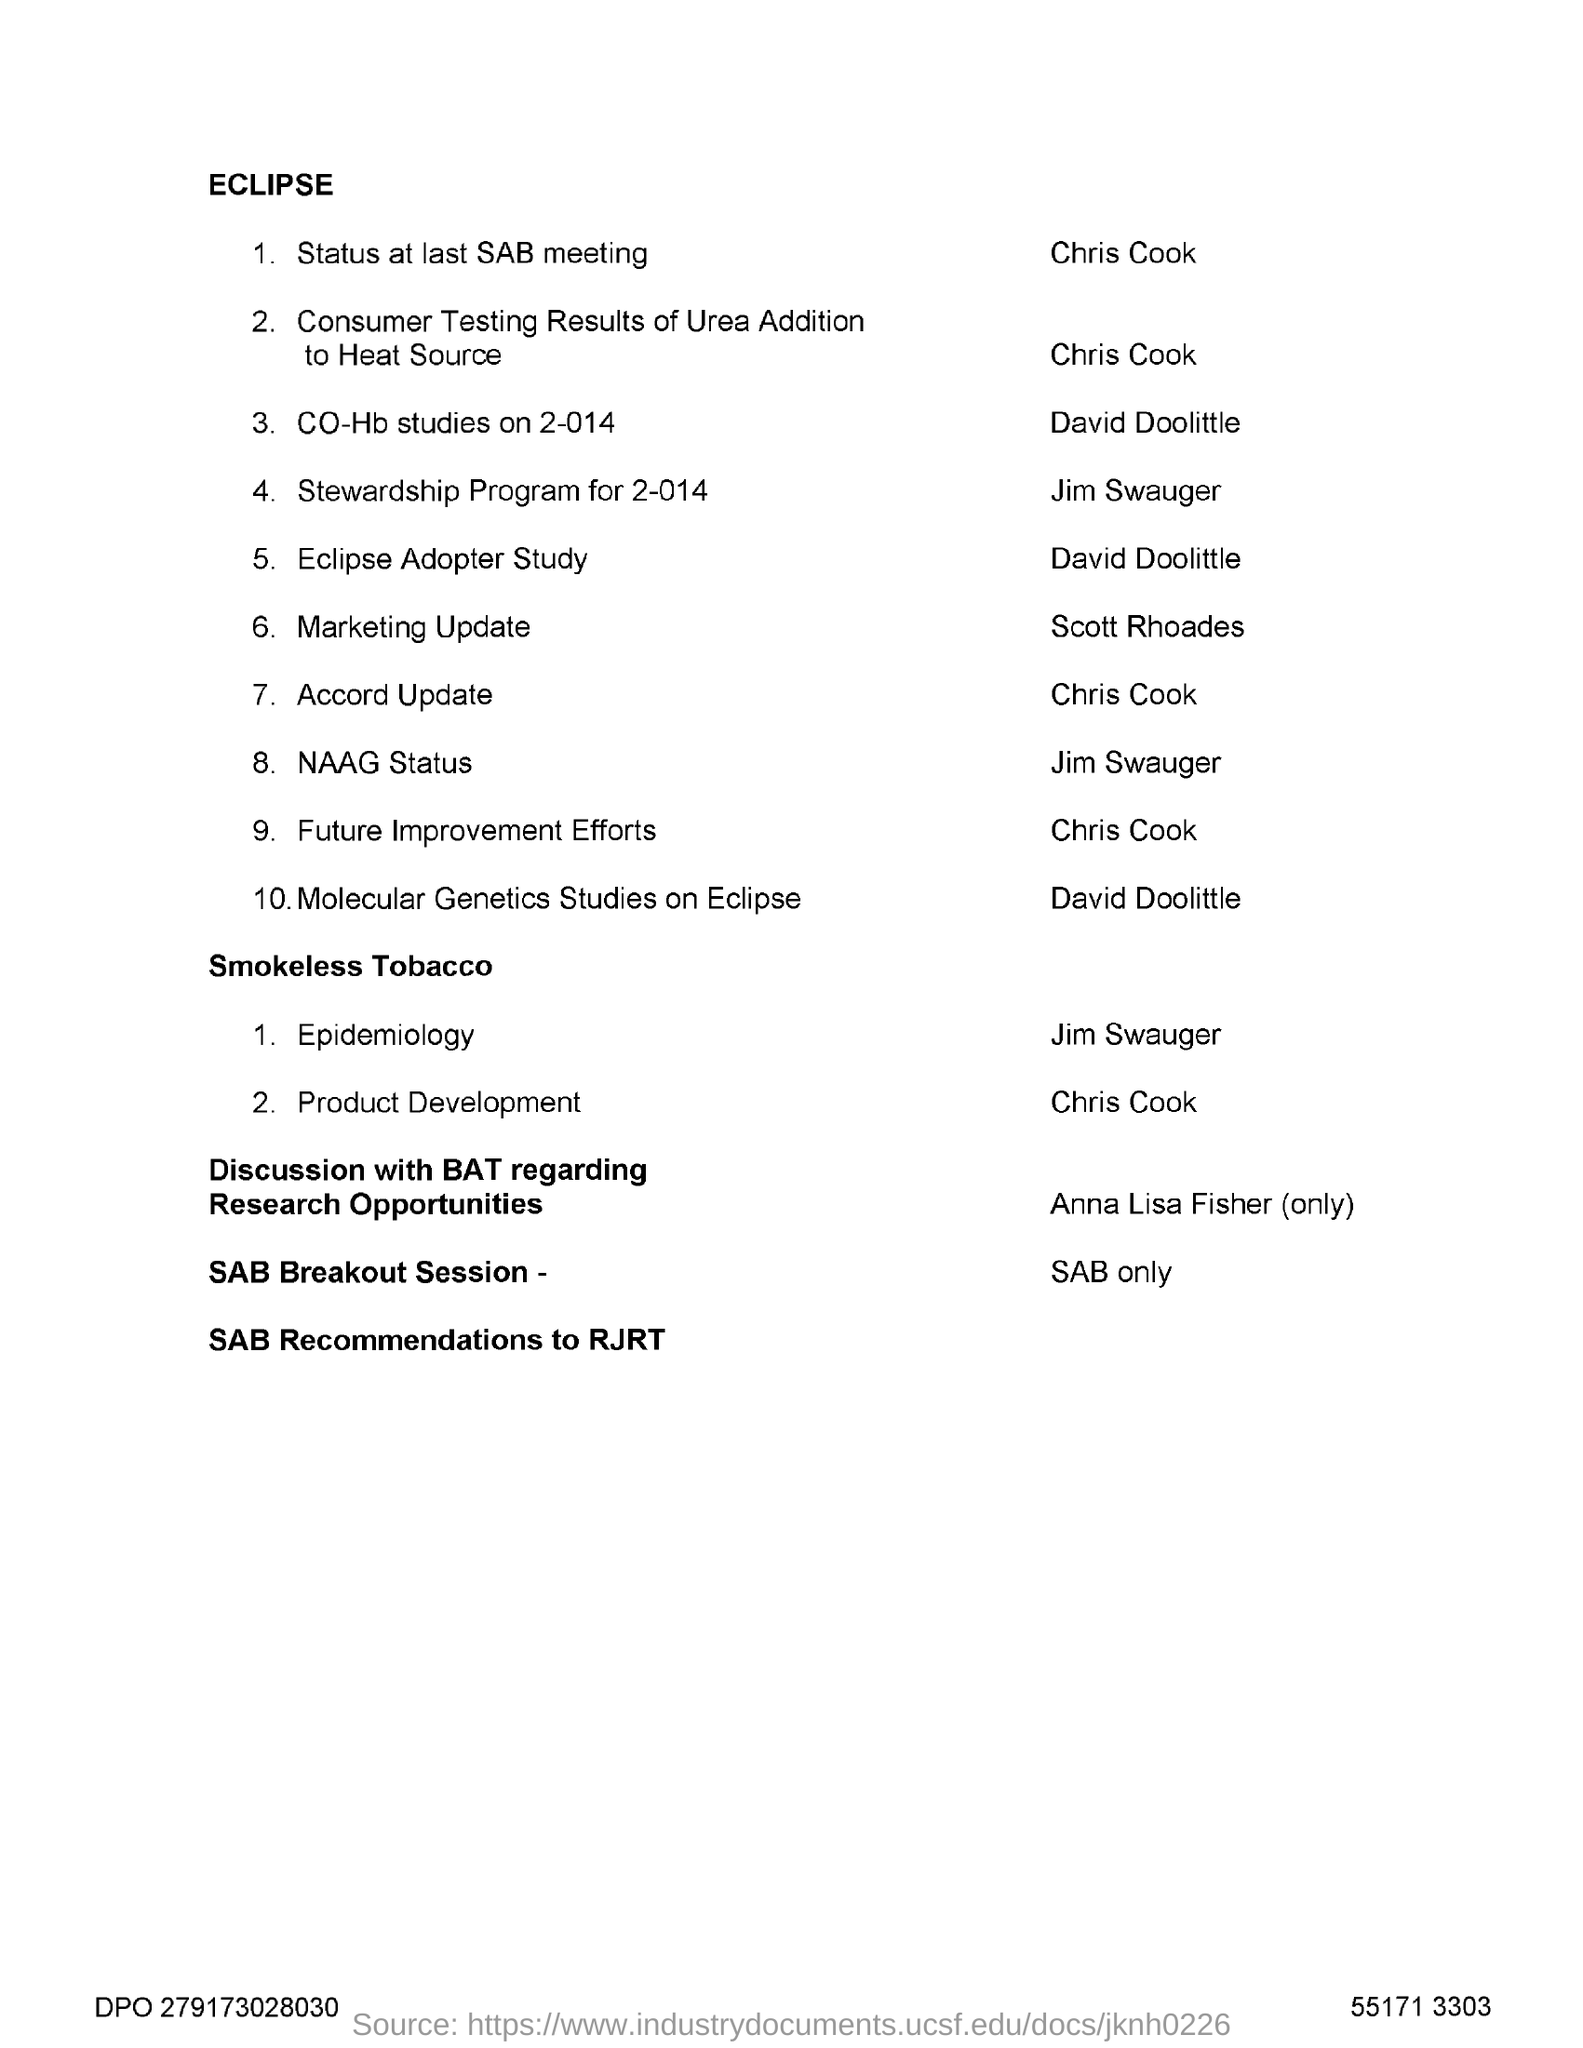What is the title of the document?
Ensure brevity in your answer.  ECLIPSE. 